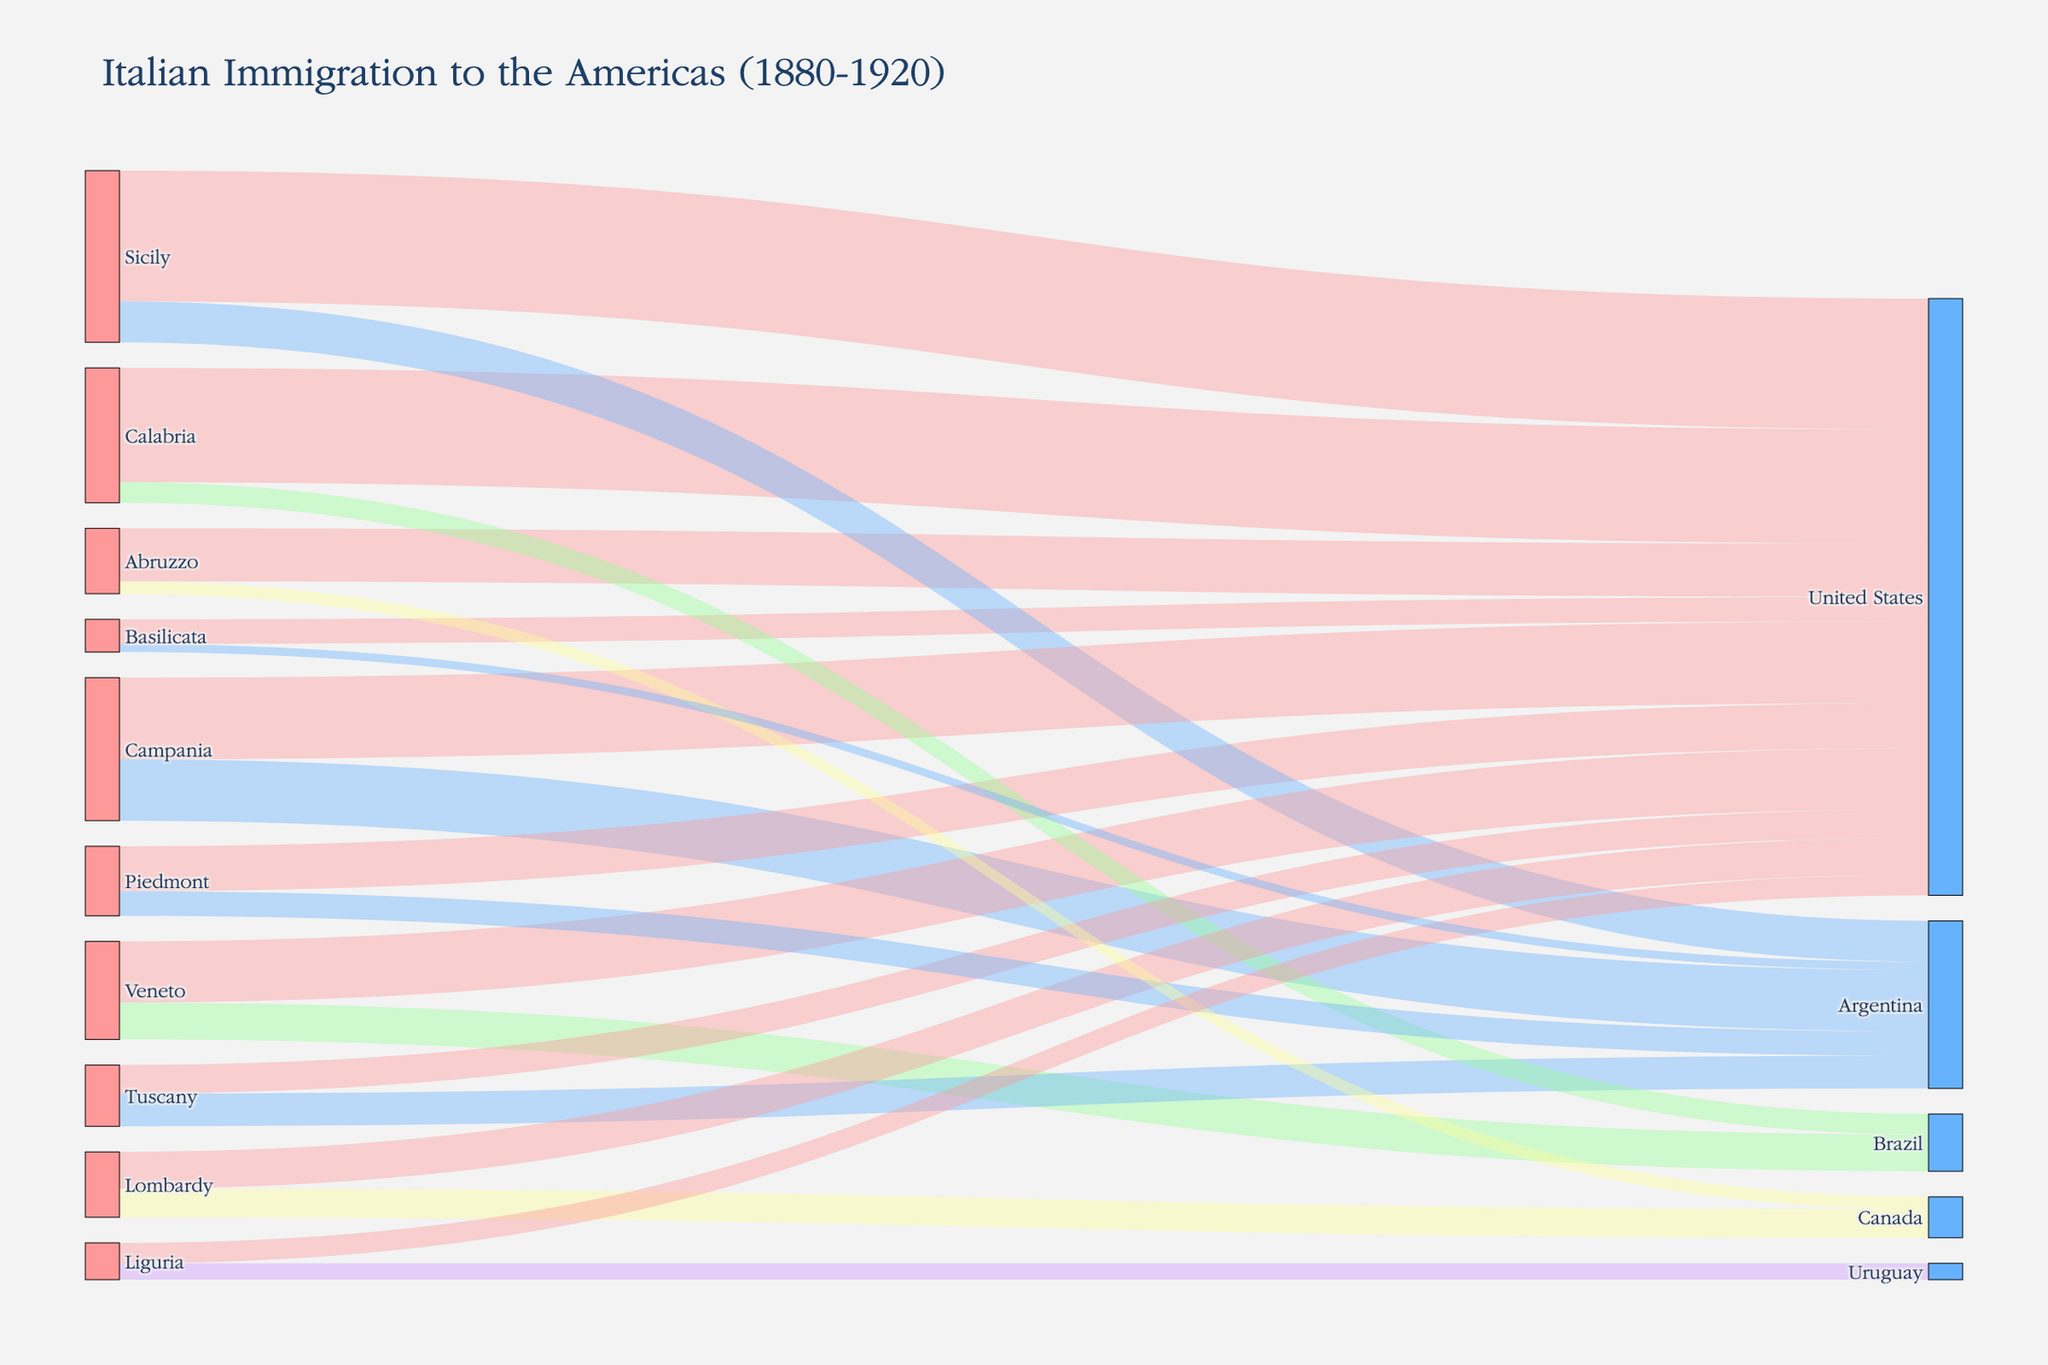Which region had the highest number of immigrants to the United States? Look at the connections leading to the United States and identify the one with the highest value. Calabria had 280,000, Sicily had 320,000, Campania had 200,000, Piedmont had 110,000, Abruzzo had 130,000, Basilicata had 60,000, Veneto had 150,000, and Lombardy had 90,000. The highest value is from Sicily with 320,000.
Answer: Sicily Which country received the largest number of Italian immigrants from Tuscany? Look at the connections from Tuscany and sum the values for each destination. Tuscany has 70,000 to the United States and 80,000 to Argentina. Argentina received more.
Answer: Argentina What is the total number of immigrants from Veneto to the Americas? Sum the values for all destinations from Veneto. Veneto sent 90,000 to Brazil and 150,000 to the United States. Adding these gives 90,000 + 150,000 = 240,000.
Answer: 240,000 How many more immigrants did Liguria send to Uruguay than to the United States? Identify the values going from Liguria to Uruguay and the United States. Liguria sent 40,000 to Uruguay and 50,000 to the United States. The difference is 50,000 - 40,000 = 10,000.
Answer: 10,000 Which region sent the least number of immigrants to Argentina? Look at the connections leading to Argentina and identify the one with the smallest value. Campania had 150,000, Sicily had 100,000, Tuscany had 80,000, Piedmont had 60,000, Basilicata had 20,000. The smallest value is from Basilicata with 20,000.
Answer: Basilicata Which two regions combined sent a total of 200,000 immigrants to Brazil? Look for connections leading to Brazil and check which two together sum to 200,000. Calabria sent 50,000, and Veneto sent 90,000. 90,000 + 50,000 = 140,000, which is not enough, so this is not applicable. There is no single combination in the given data set that adds up to 200,000.
Answer: Not applicable What percentage of total immigrants to the United States came from Campania? Sum all values leading to the United States. Total = 320,000 (Sicily) + 280,000 (Calabria) + 200,000 (Campania) + 110,000 (Piedmont) + 130,000 (Abruzzo) + 60,000 (Basilicata) + 150,000 (Veneto) + 90,000 (Lombardy) + 70,000 (Tuscany) + 50,000 (Liguria) = 1,460,000. Campania value = 200,000. Percentage = (200,000 / 1,460,000) * 100 ≈ 13.7%.
Answer: 13.7% How many Italian regions sent immigrants to Canada? Sum the unique values leading to Canada. Only Lombardy and Abruzzo sent immigrants to Canada.
Answer: 2 